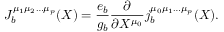Convert formula to latex. <formula><loc_0><loc_0><loc_500><loc_500>J _ { b } ^ { \mu _ { 1 } \mu _ { 2 } \dots \mu _ { p } } ( X ) = \frac { e _ { b } } { g _ { b } } \frac { \partial } { \partial X ^ { \mu _ { 0 } } } j _ { b } ^ { \mu _ { 0 } \mu _ { 1 } \dots \mu _ { p } } ( X ) .</formula> 